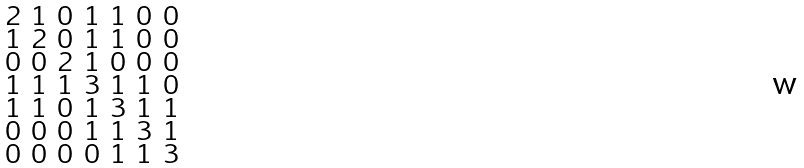<formula> <loc_0><loc_0><loc_500><loc_500>\begin{smallmatrix} 2 & 1 & 0 & 1 & 1 & 0 & 0 \\ 1 & 2 & 0 & 1 & 1 & 0 & 0 \\ 0 & 0 & 2 & 1 & 0 & 0 & 0 \\ 1 & 1 & 1 & 3 & 1 & 1 & 0 \\ 1 & 1 & 0 & 1 & 3 & 1 & 1 \\ 0 & 0 & 0 & 1 & 1 & 3 & 1 \\ 0 & 0 & 0 & 0 & 1 & 1 & 3 \end{smallmatrix}</formula> 